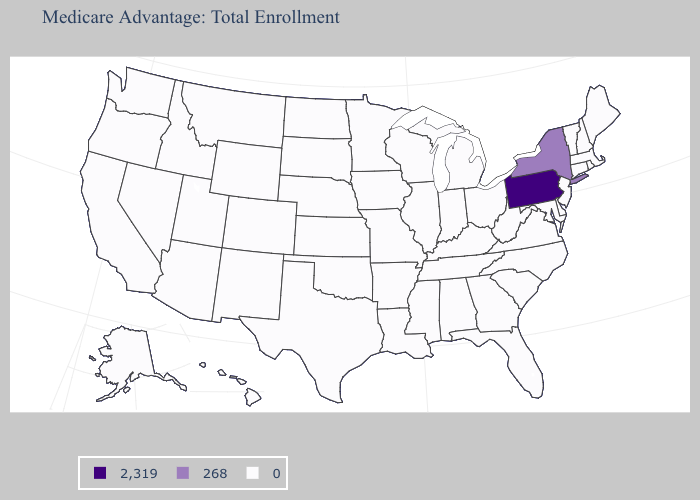How many symbols are there in the legend?
Short answer required. 3. What is the highest value in the Northeast ?
Quick response, please. 2,319. What is the value of California?
Write a very short answer. 0. What is the value of Alaska?
Write a very short answer. 0. Does New York have the lowest value in the USA?
Be succinct. No. Name the states that have a value in the range 268?
Keep it brief. New York. What is the value of North Dakota?
Be succinct. 0. Name the states that have a value in the range 2,319?
Concise answer only. Pennsylvania. What is the highest value in the USA?
Be succinct. 2,319. What is the lowest value in the Northeast?
Write a very short answer. 0. What is the value of Vermont?
Short answer required. 0. Which states have the lowest value in the Northeast?
Quick response, please. Connecticut, Massachusetts, Maine, New Hampshire, New Jersey, Rhode Island, Vermont. Which states have the lowest value in the USA?
Be succinct. Alaska, Alabama, Arkansas, Arizona, California, Colorado, Connecticut, Delaware, Florida, Georgia, Hawaii, Iowa, Idaho, Illinois, Indiana, Kansas, Kentucky, Louisiana, Massachusetts, Maryland, Maine, Michigan, Minnesota, Missouri, Mississippi, Montana, North Carolina, North Dakota, Nebraska, New Hampshire, New Jersey, New Mexico, Nevada, Ohio, Oklahoma, Oregon, Rhode Island, South Carolina, South Dakota, Tennessee, Texas, Utah, Virginia, Vermont, Washington, Wisconsin, West Virginia, Wyoming. 